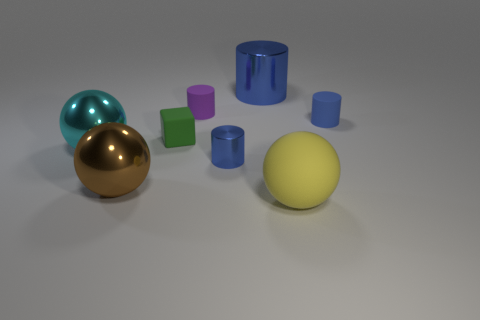Are there more tiny blue cylinders that are on the left side of the big brown object than blue things in front of the purple matte cylinder?
Your response must be concise. No. Is there any other thing that has the same color as the block?
Keep it short and to the point. No. There is a blue thing behind the purple matte object; what is it made of?
Offer a terse response. Metal. Do the cube and the cyan object have the same size?
Offer a very short reply. No. How many other objects are the same size as the brown shiny thing?
Ensure brevity in your answer.  3. Is the big rubber thing the same color as the rubber block?
Ensure brevity in your answer.  No. There is a blue metallic object that is in front of the small object on the right side of the yellow rubber object that is in front of the tiny purple cylinder; what shape is it?
Ensure brevity in your answer.  Cylinder. How many objects are either small blue things that are in front of the cyan metal thing or tiny cylinders behind the cyan ball?
Offer a terse response. 3. What size is the cylinder that is on the left side of the small blue cylinder that is in front of the tiny blue matte cylinder?
Keep it short and to the point. Small. There is a large shiny object right of the block; is its color the same as the rubber ball?
Provide a short and direct response. No. 